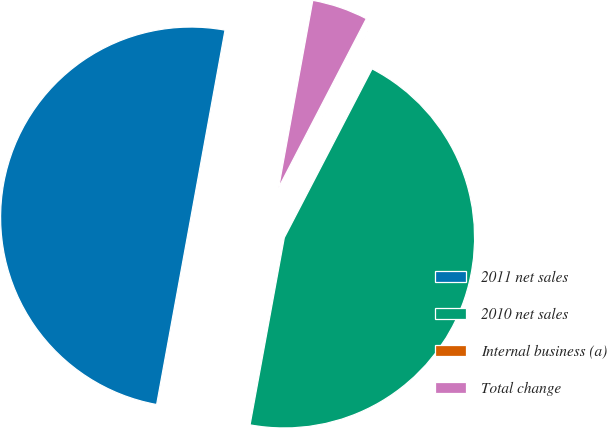Convert chart to OTSL. <chart><loc_0><loc_0><loc_500><loc_500><pie_chart><fcel>2011 net sales<fcel>2010 net sales<fcel>Internal business (a)<fcel>Total change<nl><fcel>49.99%<fcel>45.25%<fcel>0.01%<fcel>4.75%<nl></chart> 